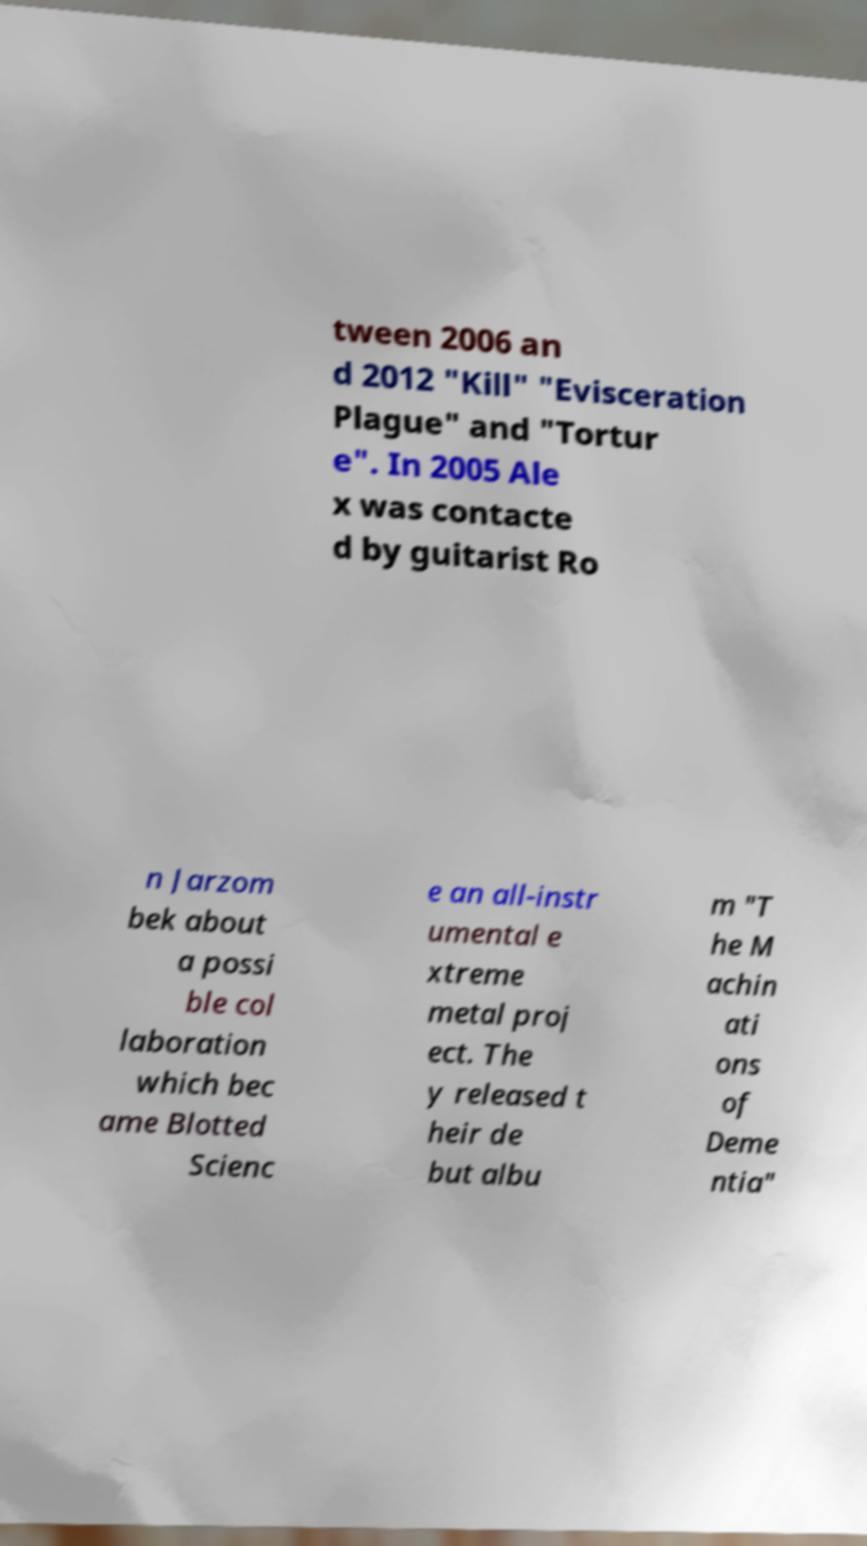I need the written content from this picture converted into text. Can you do that? tween 2006 an d 2012 "Kill" "Evisceration Plague" and "Tortur e". In 2005 Ale x was contacte d by guitarist Ro n Jarzom bek about a possi ble col laboration which bec ame Blotted Scienc e an all-instr umental e xtreme metal proj ect. The y released t heir de but albu m "T he M achin ati ons of Deme ntia" 